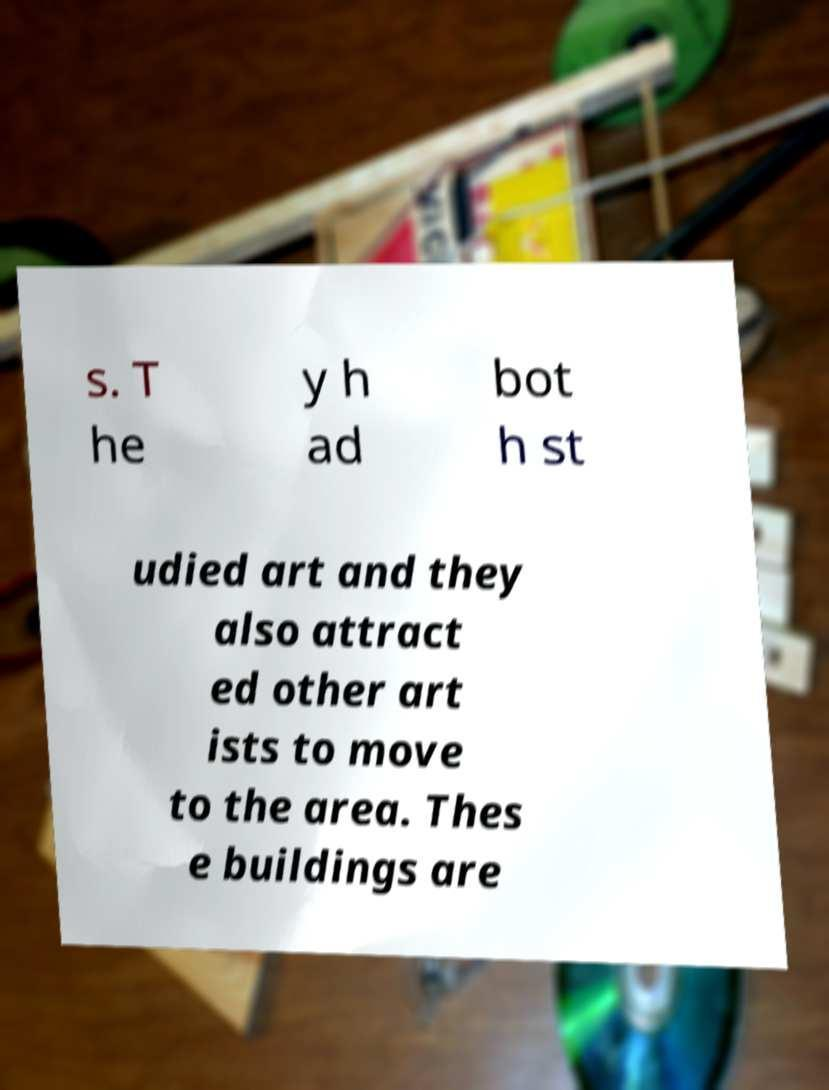I need the written content from this picture converted into text. Can you do that? s. T he y h ad bot h st udied art and they also attract ed other art ists to move to the area. Thes e buildings are 